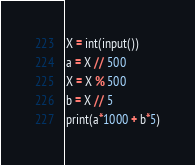<code> <loc_0><loc_0><loc_500><loc_500><_Python_>X = int(input())
a = X // 500
X = X % 500
b = X // 5
print(a*1000 + b*5)
</code> 